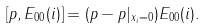<formula> <loc_0><loc_0><loc_500><loc_500>[ p , E _ { 0 0 } ( i ) ] = ( p - p | _ { x _ { i } = 0 } ) E _ { 0 0 } ( i ) .</formula> 